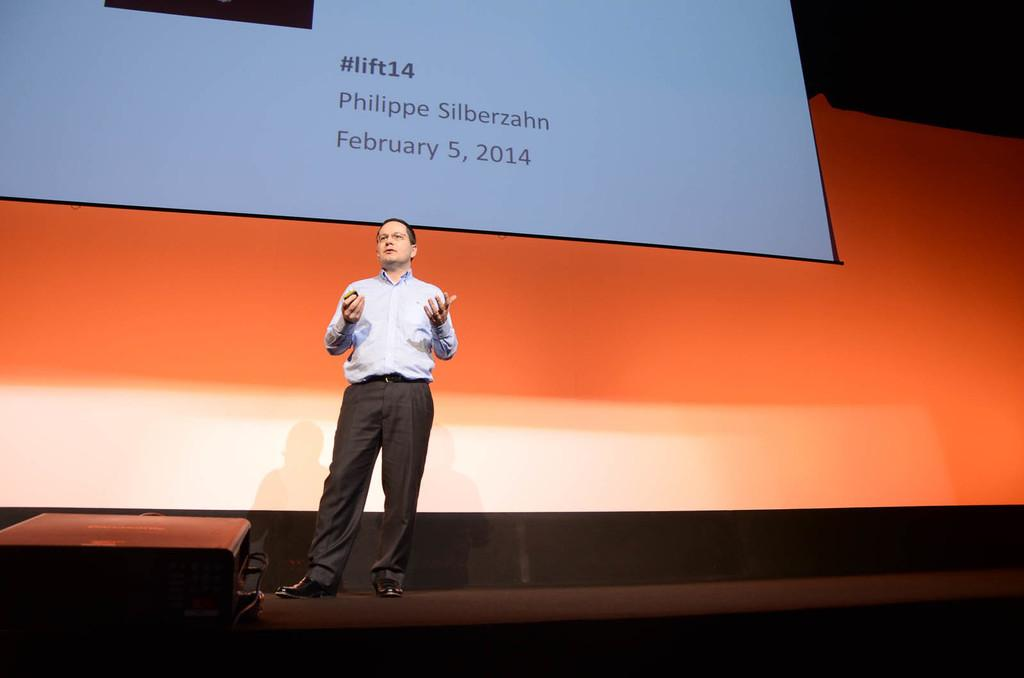What is the main subject of the image? There is a person standing in the image. What is in front of the person? There is an object in front of the person. What can be seen behind the person? There is a screen with text and numbers behind the person. Is there a cobweb visible on the person's hair in the image? There is no mention of a cobweb or any hair in the provided facts, so we cannot determine if there is a cobweb on the person's hair in the image. 